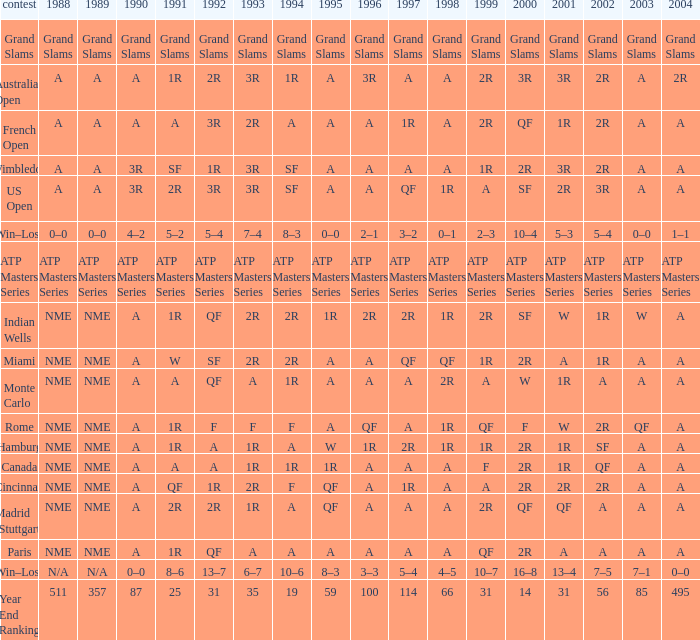What shows for 202 when the 1994 is A, the 1989 is NME, and the 199 is 2R? A. 